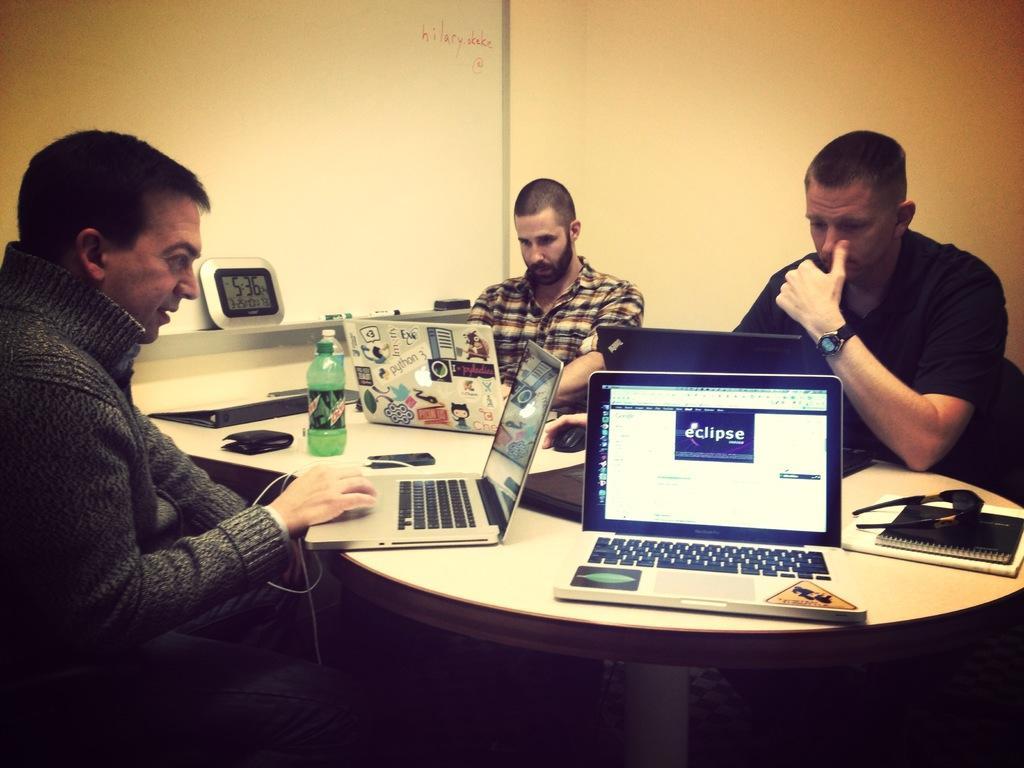How would you summarize this image in a sentence or two? In this picture we can see three persons sitting on chair and in front of them there is table and on table we can see laptop, goggles, book,bottle, purse, clock and in background we can see wall. 